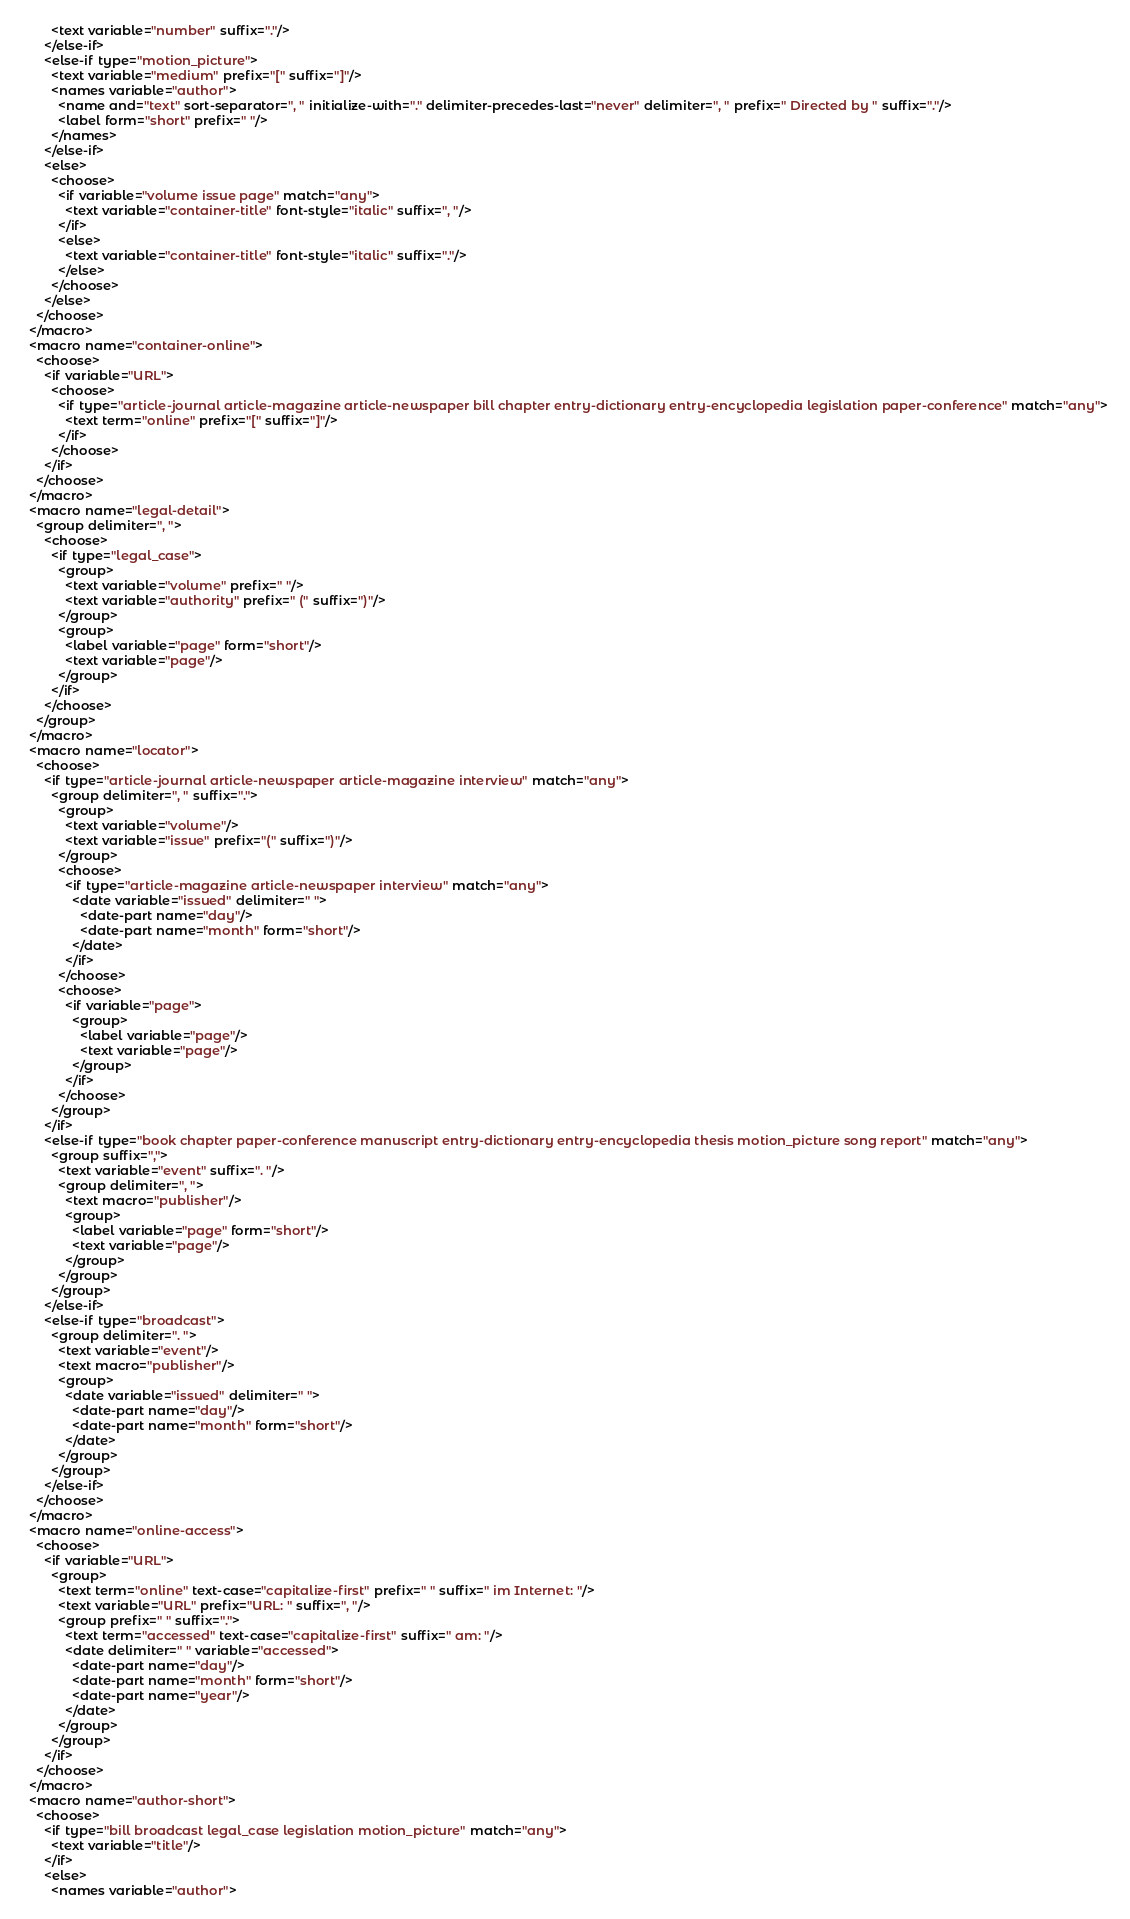<code> <loc_0><loc_0><loc_500><loc_500><_XML_>        <text variable="number" suffix="."/>
      </else-if>
      <else-if type="motion_picture">
        <text variable="medium" prefix="[" suffix="]"/>
        <names variable="author">
          <name and="text" sort-separator=", " initialize-with="." delimiter-precedes-last="never" delimiter=", " prefix=" Directed by " suffix="."/>
          <label form="short" prefix=" "/>
        </names>
      </else-if>
      <else>
        <choose>
          <if variable="volume issue page" match="any">
            <text variable="container-title" font-style="italic" suffix=", "/>
          </if>
          <else>
            <text variable="container-title" font-style="italic" suffix="."/>
          </else>
        </choose>
      </else>
    </choose>
  </macro>
  <macro name="container-online">
    <choose>
      <if variable="URL">
        <choose>
          <if type="article-journal article-magazine article-newspaper bill chapter entry-dictionary entry-encyclopedia legislation paper-conference" match="any">
            <text term="online" prefix="[" suffix="]"/>
          </if>
        </choose>
      </if>
    </choose>
  </macro>
  <macro name="legal-detail">
    <group delimiter=", ">
      <choose>
        <if type="legal_case">
          <group>
            <text variable="volume" prefix=" "/>
            <text variable="authority" prefix=" (" suffix=")"/>
          </group>
          <group>
            <label variable="page" form="short"/>
            <text variable="page"/>
          </group>
        </if>
      </choose>
    </group>
  </macro>
  <macro name="locator">
    <choose>
      <if type="article-journal article-newspaper article-magazine interview" match="any">
        <group delimiter=", " suffix=".">
          <group>
            <text variable="volume"/>
            <text variable="issue" prefix="(" suffix=")"/>
          </group>
          <choose>
            <if type="article-magazine article-newspaper interview" match="any">
              <date variable="issued" delimiter=" ">
                <date-part name="day"/>
                <date-part name="month" form="short"/>
              </date>
            </if>
          </choose>
          <choose>
            <if variable="page">
              <group>
                <label variable="page"/>
                <text variable="page"/>
              </group>
            </if>
          </choose>
        </group>
      </if>
      <else-if type="book chapter paper-conference manuscript entry-dictionary entry-encyclopedia thesis motion_picture song report" match="any">
        <group suffix=",">
          <text variable="event" suffix=". "/>
          <group delimiter=", ">
            <text macro="publisher"/>
            <group>
              <label variable="page" form="short"/>
              <text variable="page"/>
            </group>
          </group>
        </group>
      </else-if>
      <else-if type="broadcast">
        <group delimiter=". ">
          <text variable="event"/>
          <text macro="publisher"/>
          <group>
            <date variable="issued" delimiter=" ">
              <date-part name="day"/>
              <date-part name="month" form="short"/>
            </date>
          </group>
        </group>
      </else-if>
    </choose>
  </macro>
  <macro name="online-access">
    <choose>
      <if variable="URL">
        <group>
          <text term="online" text-case="capitalize-first" prefix=" " suffix=" im Internet: "/>
          <text variable="URL" prefix="URL: " suffix=", "/>
          <group prefix=" " suffix=".">
            <text term="accessed" text-case="capitalize-first" suffix=" am: "/>
            <date delimiter=" " variable="accessed">
              <date-part name="day"/>
              <date-part name="month" form="short"/>
              <date-part name="year"/>
            </date>
          </group>
        </group>
      </if>
    </choose>
  </macro>
  <macro name="author-short">
    <choose>
      <if type="bill broadcast legal_case legislation motion_picture" match="any">
        <text variable="title"/>
      </if>
      <else>
        <names variable="author"></code> 